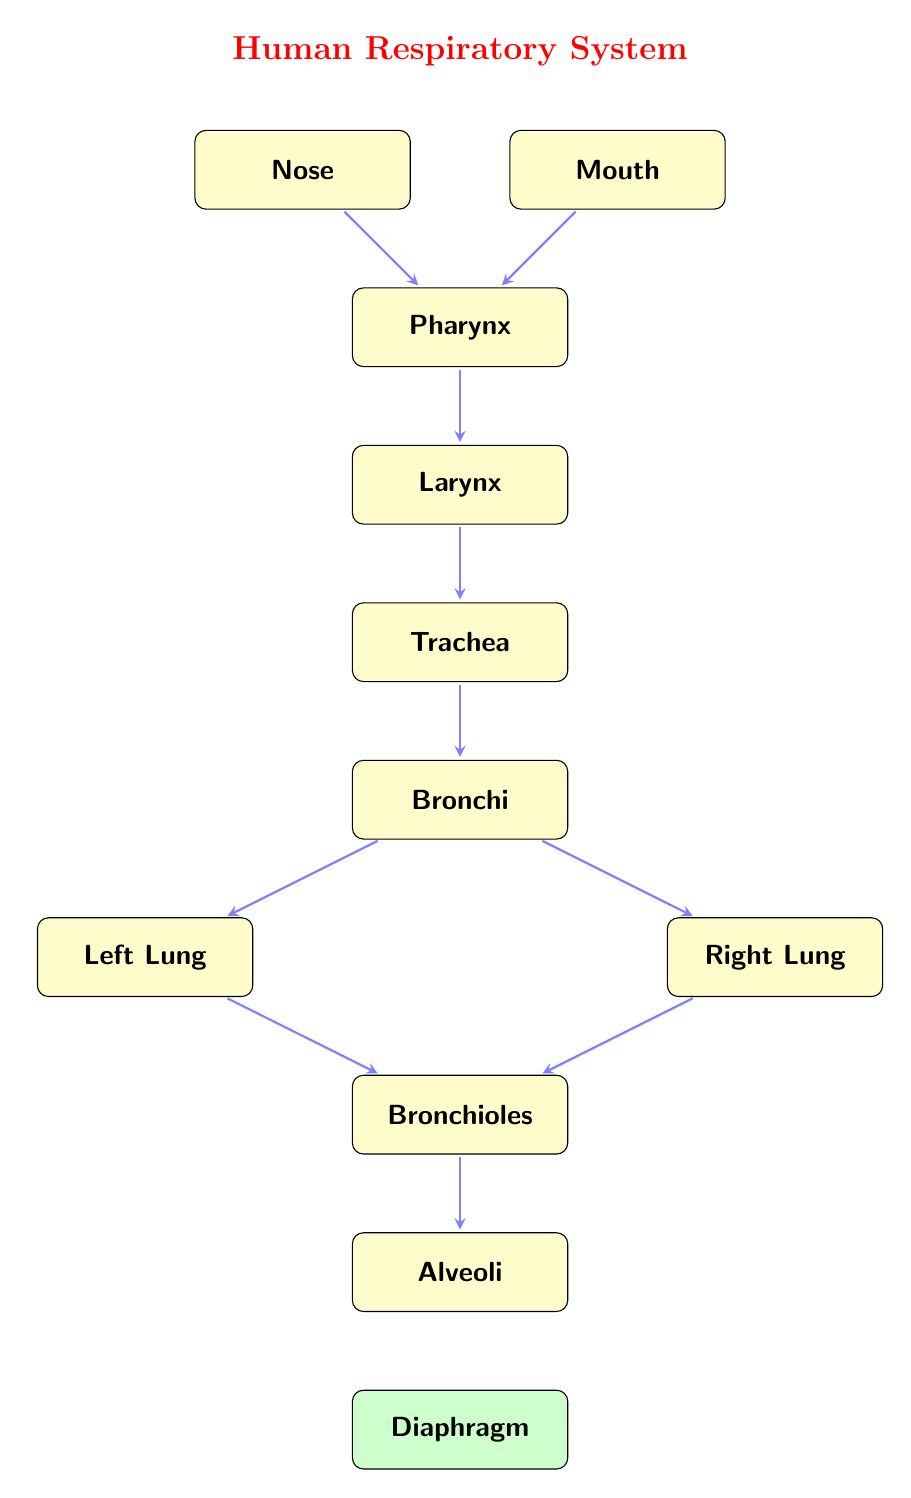What is the first part of the respiratory system that air enters? The diagram indicates that air can enter through either the nose or the mouth, both of which are shown at the top. Therefore, either one of these can be considered the starting point depending on the path taken by the incoming air.
Answer: Nose or Mouth How many lungs are shown in the diagram? The diagram clearly depicts two lungs: the left lung and the right lung, positioned on either side of the central bronchi. Thus, the count of lungs delivered by the diagram is two.
Answer: Two What is the last part of the respiratory system before air reaches the alveoli? According to the diagram, after the bronchi, the airflow proceeds to the bronchioles before the alveoli. Hence, bronchioles are the last segment air passes through before reaching the alveoli.
Answer: Bronchioles What is the function of the diaphragm in the respiratory system? The diaphragm, located at the bottom of the diagram, plays a crucial role in the respiratory process, enabling the expansion and contraction of the lungs during inhalation and exhalation. It is essential for the mechanics of breathing.
Answer: Muscle in breathing What direction does airflow follow from the trachea to the lungs? The arrows in the diagram indicate that airflow moves from the trachea to the bronchi, and then splits to move toward both the left and right lungs. This flow direction is quite clear in the visual representation provided.
Answer: Downward Which structure comes directly after the pharynx in the airflow path? Following the arrows in the diagram, it is evident that the airflow proceeds from the pharynx to the larynx. Therefore, larynx is the immediate next structure in the sequence of air passage.
Answer: Larynx How many pathways lead from the trachea to the lungs? The diagram indicates that from the trachea, the airflow can split into two main pathways, one leading towards the left lung and the other towards the right lung. Thus, the total pathways are two.
Answer: Two What is the role of the alveoli in the respiratory system? Alveoli are tiny air sacs, and they are the final destination of the airflow in the diagram. Their main function is to facilitate the exchange of oxygen and carbon dioxide between the air and the bloodstream.
Answer: Gas exchange 